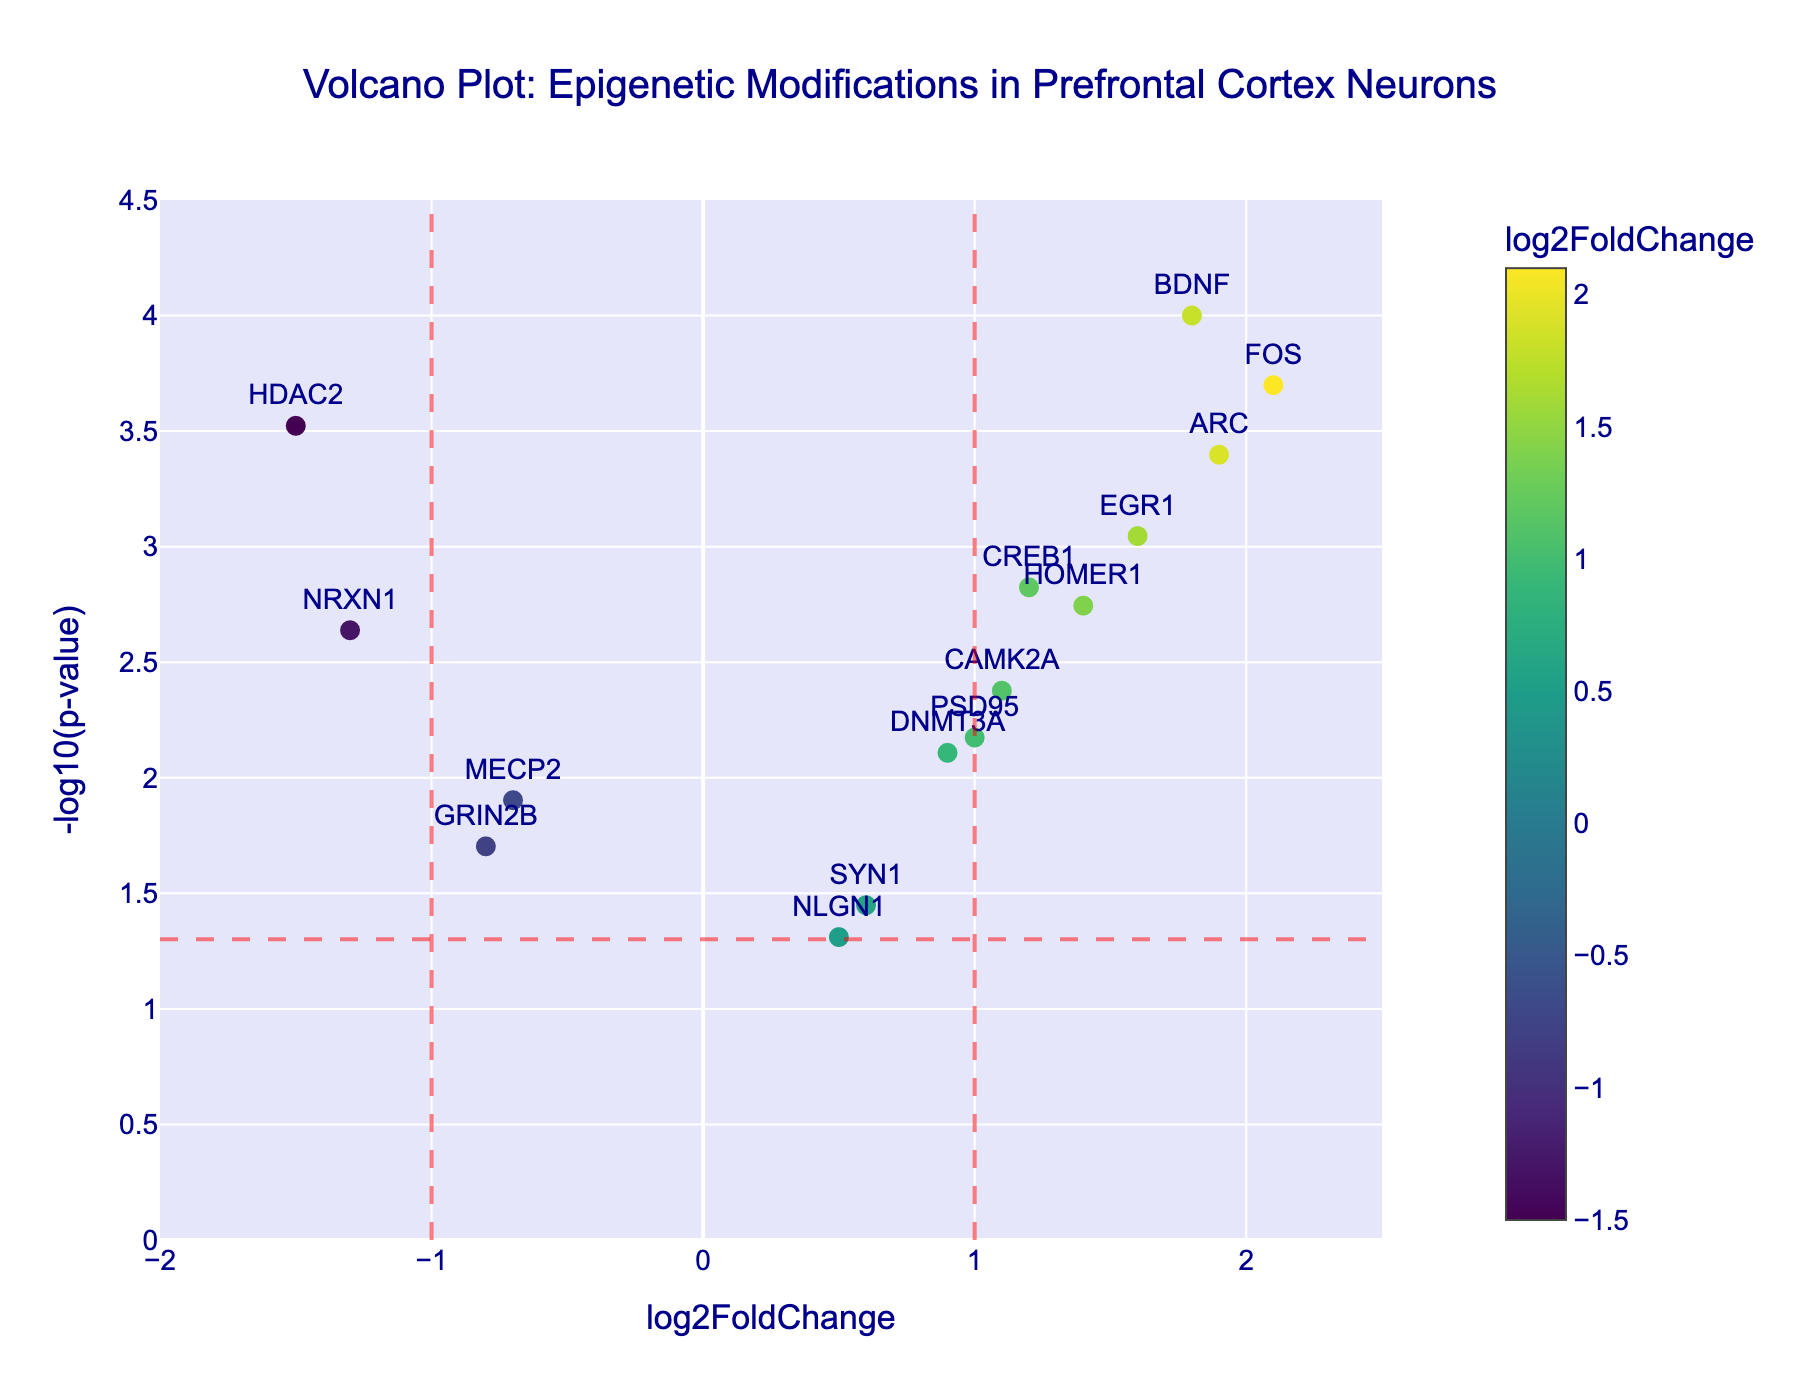How many genes have a log2FoldChange greater than 1? We need to count the genes that have a log2FoldChange value greater than 1. These genes are BDNF, FOS, EGR1, ARC, CREB1, HOMER1, PSD95, and CAMK2A.
Answer: 8 Which gene has the highest log2FoldChange? We need to find the gene with the highest log2FoldChange value among all genes. It's FOS with a log2FoldChange of 2.1.
Answer: FOS How many genes are significantly differentially expressed (p-value < 0.05)? We need to count the genes with a p-value less than 0.05. These genes are BDNF, HDAC2, CREB1, DNMT3A, MECP2, FOS, EGR1, ARC, SYN1, CAMK2A, GRIN2B, NRXN1, HOMER1, and PSD95.
Answer: 14 Which gene has the smallest p-value? We need to identify the gene with the smallest p-value. It's BDNF with a p-value of 0.0001.
Answer: BDNF Which gene has the largest -log10(p-value)? The -log10(p-value) transforms the p-value into -log10 scale. The lowest p-value corresponds to the largest -log10(p-value). BDNF has the largest -log10(p-value) of 4.
Answer: BDNF Which genes have a log2FoldChange close to zero (between -0.5 and 0.5)? We look at genes with log2FoldChange values between -0.5 and 0.5. The genes are SYN1 and NLGN1.
Answer: SYN1, NLGN1 Are there more upregulated genes (log2FoldChange > 0) or downregulated genes (log2FoldChange < 0)? Count the number of genes with positive log2FoldChange (upregulated) and negative log2FoldChange (downregulated). There are more upregulated genes (10) than downregulated genes (4).
Answer: Upregulated Which genes lie within the region defined by -1 < log2FoldChange < 1 and are also significant (p-value < 0.05)? Identify genes meeting both conditions: -1 < log2FoldChange < 1 and p-value < 0.05. The genes are DNMT3A, MECP2, SYN1, and GRIN2B.
Answer: DNMT3A, MECP2, SYN1, GRIN2B How many genes are shown beyond the vertical lines at log2FoldChange of -1 and 1? Count the genes that have log2FoldChange values greater than 1 or less than -1. There are BDNF, HDAC2, FOS, EGR1, ARC, and NRXN1.
Answer: 6 Which gene has the smallest negative log2FoldChange and what is its p-value? Identify the gene with the smallest log2FoldChange value among the negative ones and note its p-value. It's HDAC2 with a log2FoldChange of -1.5 and a p-value of 0.0003.
Answer: HDAC2, 0.0003 